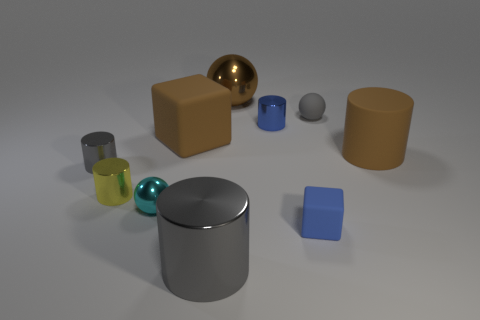Are the tiny gray object that is behind the big brown block and the gray cylinder that is on the left side of the large gray cylinder made of the same material?
Make the answer very short. No. Do the tiny matte sphere and the metal thing that is behind the blue cylinder have the same color?
Offer a terse response. No. There is a thing that is both right of the blue shiny cylinder and in front of the cyan shiny thing; what is its shape?
Keep it short and to the point. Cube. How many tiny green rubber balls are there?
Your response must be concise. 0. The metallic thing that is the same color as the large rubber cube is what shape?
Your answer should be very brief. Sphere. The blue shiny object that is the same shape as the tiny yellow object is what size?
Your response must be concise. Small. There is a tiny gray thing that is behind the small blue metallic thing; is it the same shape as the cyan shiny thing?
Make the answer very short. Yes. What is the color of the block behind the tiny gray cylinder?
Give a very brief answer. Brown. How many other objects are there of the same size as the cyan metal thing?
Your answer should be very brief. 5. Is the number of tiny blue cubes that are to the right of the gray sphere the same as the number of small red things?
Your response must be concise. Yes. 